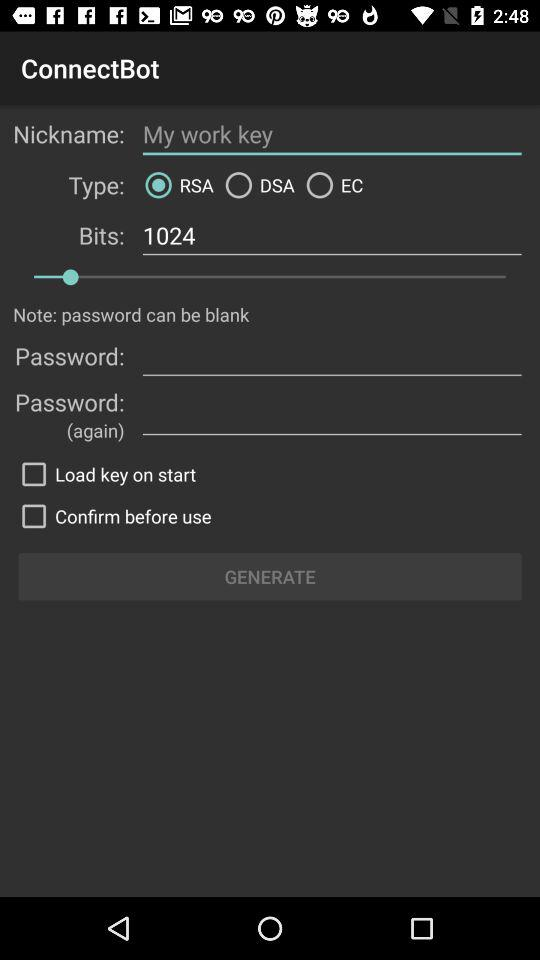What is the status of the load key on start? The status is off. 